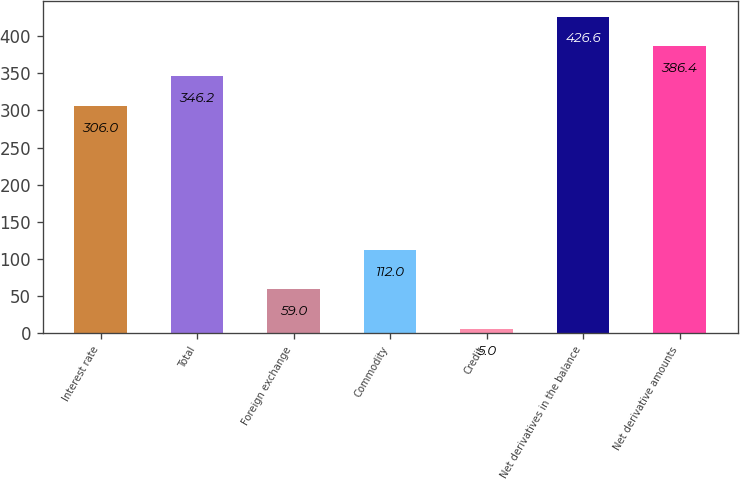Convert chart. <chart><loc_0><loc_0><loc_500><loc_500><bar_chart><fcel>Interest rate<fcel>Total<fcel>Foreign exchange<fcel>Commodity<fcel>Credit<fcel>Net derivatives in the balance<fcel>Net derivative amounts<nl><fcel>306<fcel>346.2<fcel>59<fcel>112<fcel>5<fcel>426.6<fcel>386.4<nl></chart> 